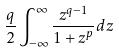<formula> <loc_0><loc_0><loc_500><loc_500>\frac { q } { 2 } \int _ { - \infty } ^ { \infty } \frac { z ^ { q - 1 } } { 1 + z ^ { p } } d z</formula> 